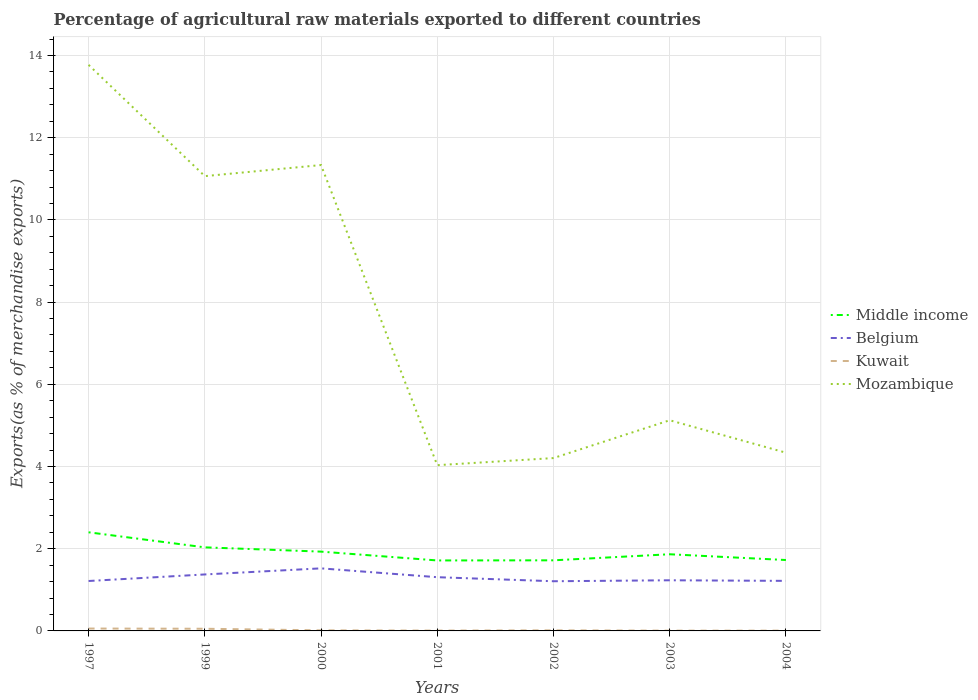How many different coloured lines are there?
Make the answer very short. 4. Is the number of lines equal to the number of legend labels?
Ensure brevity in your answer.  Yes. Across all years, what is the maximum percentage of exports to different countries in Belgium?
Provide a short and direct response. 1.21. What is the total percentage of exports to different countries in Kuwait in the graph?
Offer a terse response. 5.218391852740076e-5. What is the difference between the highest and the second highest percentage of exports to different countries in Middle income?
Your answer should be very brief. 0.68. How many lines are there?
Your answer should be compact. 4. How many years are there in the graph?
Make the answer very short. 7. What is the difference between two consecutive major ticks on the Y-axis?
Make the answer very short. 2. Are the values on the major ticks of Y-axis written in scientific E-notation?
Offer a terse response. No. Where does the legend appear in the graph?
Provide a short and direct response. Center right. How many legend labels are there?
Give a very brief answer. 4. What is the title of the graph?
Ensure brevity in your answer.  Percentage of agricultural raw materials exported to different countries. What is the label or title of the X-axis?
Your answer should be very brief. Years. What is the label or title of the Y-axis?
Keep it short and to the point. Exports(as % of merchandise exports). What is the Exports(as % of merchandise exports) of Middle income in 1997?
Your answer should be very brief. 2.4. What is the Exports(as % of merchandise exports) of Belgium in 1997?
Offer a very short reply. 1.21. What is the Exports(as % of merchandise exports) in Kuwait in 1997?
Keep it short and to the point. 0.06. What is the Exports(as % of merchandise exports) of Mozambique in 1997?
Make the answer very short. 13.77. What is the Exports(as % of merchandise exports) in Middle income in 1999?
Keep it short and to the point. 2.03. What is the Exports(as % of merchandise exports) of Belgium in 1999?
Offer a very short reply. 1.37. What is the Exports(as % of merchandise exports) in Kuwait in 1999?
Your answer should be compact. 0.05. What is the Exports(as % of merchandise exports) of Mozambique in 1999?
Offer a very short reply. 11.07. What is the Exports(as % of merchandise exports) of Middle income in 2000?
Your answer should be compact. 1.93. What is the Exports(as % of merchandise exports) in Belgium in 2000?
Offer a very short reply. 1.52. What is the Exports(as % of merchandise exports) of Kuwait in 2000?
Keep it short and to the point. 0.01. What is the Exports(as % of merchandise exports) of Mozambique in 2000?
Ensure brevity in your answer.  11.33. What is the Exports(as % of merchandise exports) in Middle income in 2001?
Keep it short and to the point. 1.71. What is the Exports(as % of merchandise exports) of Belgium in 2001?
Offer a very short reply. 1.31. What is the Exports(as % of merchandise exports) of Kuwait in 2001?
Make the answer very short. 0.01. What is the Exports(as % of merchandise exports) of Mozambique in 2001?
Provide a short and direct response. 4.03. What is the Exports(as % of merchandise exports) of Middle income in 2002?
Your response must be concise. 1.72. What is the Exports(as % of merchandise exports) in Belgium in 2002?
Offer a terse response. 1.21. What is the Exports(as % of merchandise exports) in Kuwait in 2002?
Your answer should be very brief. 0.01. What is the Exports(as % of merchandise exports) of Mozambique in 2002?
Make the answer very short. 4.21. What is the Exports(as % of merchandise exports) of Middle income in 2003?
Your answer should be very brief. 1.87. What is the Exports(as % of merchandise exports) in Belgium in 2003?
Provide a short and direct response. 1.23. What is the Exports(as % of merchandise exports) in Kuwait in 2003?
Keep it short and to the point. 0.01. What is the Exports(as % of merchandise exports) in Mozambique in 2003?
Offer a very short reply. 5.13. What is the Exports(as % of merchandise exports) in Middle income in 2004?
Ensure brevity in your answer.  1.73. What is the Exports(as % of merchandise exports) of Belgium in 2004?
Give a very brief answer. 1.22. What is the Exports(as % of merchandise exports) in Kuwait in 2004?
Offer a very short reply. 0.01. What is the Exports(as % of merchandise exports) of Mozambique in 2004?
Your answer should be very brief. 4.34. Across all years, what is the maximum Exports(as % of merchandise exports) in Middle income?
Your answer should be very brief. 2.4. Across all years, what is the maximum Exports(as % of merchandise exports) of Belgium?
Your answer should be compact. 1.52. Across all years, what is the maximum Exports(as % of merchandise exports) in Kuwait?
Give a very brief answer. 0.06. Across all years, what is the maximum Exports(as % of merchandise exports) of Mozambique?
Give a very brief answer. 13.77. Across all years, what is the minimum Exports(as % of merchandise exports) of Middle income?
Your response must be concise. 1.71. Across all years, what is the minimum Exports(as % of merchandise exports) in Belgium?
Provide a succinct answer. 1.21. Across all years, what is the minimum Exports(as % of merchandise exports) in Kuwait?
Give a very brief answer. 0.01. Across all years, what is the minimum Exports(as % of merchandise exports) in Mozambique?
Offer a very short reply. 4.03. What is the total Exports(as % of merchandise exports) in Middle income in the graph?
Make the answer very short. 13.38. What is the total Exports(as % of merchandise exports) in Belgium in the graph?
Offer a very short reply. 9.08. What is the total Exports(as % of merchandise exports) of Kuwait in the graph?
Ensure brevity in your answer.  0.16. What is the total Exports(as % of merchandise exports) in Mozambique in the graph?
Keep it short and to the point. 53.87. What is the difference between the Exports(as % of merchandise exports) of Middle income in 1997 and that in 1999?
Offer a terse response. 0.37. What is the difference between the Exports(as % of merchandise exports) in Belgium in 1997 and that in 1999?
Provide a short and direct response. -0.16. What is the difference between the Exports(as % of merchandise exports) in Kuwait in 1997 and that in 1999?
Keep it short and to the point. 0.01. What is the difference between the Exports(as % of merchandise exports) of Mozambique in 1997 and that in 1999?
Make the answer very short. 2.71. What is the difference between the Exports(as % of merchandise exports) of Middle income in 1997 and that in 2000?
Offer a terse response. 0.47. What is the difference between the Exports(as % of merchandise exports) in Belgium in 1997 and that in 2000?
Your answer should be compact. -0.31. What is the difference between the Exports(as % of merchandise exports) of Kuwait in 1997 and that in 2000?
Your response must be concise. 0.04. What is the difference between the Exports(as % of merchandise exports) in Mozambique in 1997 and that in 2000?
Your answer should be compact. 2.44. What is the difference between the Exports(as % of merchandise exports) of Middle income in 1997 and that in 2001?
Keep it short and to the point. 0.69. What is the difference between the Exports(as % of merchandise exports) in Belgium in 1997 and that in 2001?
Provide a short and direct response. -0.09. What is the difference between the Exports(as % of merchandise exports) in Kuwait in 1997 and that in 2001?
Provide a short and direct response. 0.05. What is the difference between the Exports(as % of merchandise exports) of Mozambique in 1997 and that in 2001?
Offer a very short reply. 9.74. What is the difference between the Exports(as % of merchandise exports) in Middle income in 1997 and that in 2002?
Your response must be concise. 0.68. What is the difference between the Exports(as % of merchandise exports) of Belgium in 1997 and that in 2002?
Provide a succinct answer. 0.01. What is the difference between the Exports(as % of merchandise exports) in Kuwait in 1997 and that in 2002?
Provide a short and direct response. 0.04. What is the difference between the Exports(as % of merchandise exports) of Mozambique in 1997 and that in 2002?
Provide a short and direct response. 9.57. What is the difference between the Exports(as % of merchandise exports) in Middle income in 1997 and that in 2003?
Keep it short and to the point. 0.53. What is the difference between the Exports(as % of merchandise exports) in Belgium in 1997 and that in 2003?
Ensure brevity in your answer.  -0.02. What is the difference between the Exports(as % of merchandise exports) in Kuwait in 1997 and that in 2003?
Your answer should be compact. 0.05. What is the difference between the Exports(as % of merchandise exports) of Mozambique in 1997 and that in 2003?
Keep it short and to the point. 8.65. What is the difference between the Exports(as % of merchandise exports) in Middle income in 1997 and that in 2004?
Keep it short and to the point. 0.67. What is the difference between the Exports(as % of merchandise exports) of Belgium in 1997 and that in 2004?
Provide a short and direct response. -0. What is the difference between the Exports(as % of merchandise exports) of Kuwait in 1997 and that in 2004?
Offer a very short reply. 0.05. What is the difference between the Exports(as % of merchandise exports) in Mozambique in 1997 and that in 2004?
Ensure brevity in your answer.  9.44. What is the difference between the Exports(as % of merchandise exports) of Middle income in 1999 and that in 2000?
Keep it short and to the point. 0.1. What is the difference between the Exports(as % of merchandise exports) in Belgium in 1999 and that in 2000?
Provide a short and direct response. -0.15. What is the difference between the Exports(as % of merchandise exports) in Kuwait in 1999 and that in 2000?
Provide a short and direct response. 0.04. What is the difference between the Exports(as % of merchandise exports) of Mozambique in 1999 and that in 2000?
Make the answer very short. -0.27. What is the difference between the Exports(as % of merchandise exports) of Middle income in 1999 and that in 2001?
Keep it short and to the point. 0.32. What is the difference between the Exports(as % of merchandise exports) of Belgium in 1999 and that in 2001?
Your answer should be compact. 0.07. What is the difference between the Exports(as % of merchandise exports) in Kuwait in 1999 and that in 2001?
Make the answer very short. 0.04. What is the difference between the Exports(as % of merchandise exports) of Mozambique in 1999 and that in 2001?
Keep it short and to the point. 7.03. What is the difference between the Exports(as % of merchandise exports) in Middle income in 1999 and that in 2002?
Your answer should be compact. 0.32. What is the difference between the Exports(as % of merchandise exports) of Belgium in 1999 and that in 2002?
Your answer should be very brief. 0.17. What is the difference between the Exports(as % of merchandise exports) in Kuwait in 1999 and that in 2002?
Keep it short and to the point. 0.04. What is the difference between the Exports(as % of merchandise exports) in Mozambique in 1999 and that in 2002?
Your response must be concise. 6.86. What is the difference between the Exports(as % of merchandise exports) in Middle income in 1999 and that in 2003?
Ensure brevity in your answer.  0.17. What is the difference between the Exports(as % of merchandise exports) in Belgium in 1999 and that in 2003?
Your response must be concise. 0.14. What is the difference between the Exports(as % of merchandise exports) in Kuwait in 1999 and that in 2003?
Your answer should be very brief. 0.05. What is the difference between the Exports(as % of merchandise exports) of Mozambique in 1999 and that in 2003?
Offer a terse response. 5.94. What is the difference between the Exports(as % of merchandise exports) of Middle income in 1999 and that in 2004?
Keep it short and to the point. 0.31. What is the difference between the Exports(as % of merchandise exports) in Belgium in 1999 and that in 2004?
Provide a succinct answer. 0.16. What is the difference between the Exports(as % of merchandise exports) in Kuwait in 1999 and that in 2004?
Offer a terse response. 0.05. What is the difference between the Exports(as % of merchandise exports) in Mozambique in 1999 and that in 2004?
Your response must be concise. 6.73. What is the difference between the Exports(as % of merchandise exports) in Middle income in 2000 and that in 2001?
Keep it short and to the point. 0.21. What is the difference between the Exports(as % of merchandise exports) in Belgium in 2000 and that in 2001?
Make the answer very short. 0.21. What is the difference between the Exports(as % of merchandise exports) in Kuwait in 2000 and that in 2001?
Give a very brief answer. 0.01. What is the difference between the Exports(as % of merchandise exports) in Mozambique in 2000 and that in 2001?
Make the answer very short. 7.3. What is the difference between the Exports(as % of merchandise exports) in Middle income in 2000 and that in 2002?
Give a very brief answer. 0.21. What is the difference between the Exports(as % of merchandise exports) of Belgium in 2000 and that in 2002?
Your answer should be compact. 0.31. What is the difference between the Exports(as % of merchandise exports) of Kuwait in 2000 and that in 2002?
Provide a succinct answer. -0. What is the difference between the Exports(as % of merchandise exports) in Mozambique in 2000 and that in 2002?
Your answer should be compact. 7.13. What is the difference between the Exports(as % of merchandise exports) of Middle income in 2000 and that in 2003?
Ensure brevity in your answer.  0.06. What is the difference between the Exports(as % of merchandise exports) of Belgium in 2000 and that in 2003?
Provide a succinct answer. 0.29. What is the difference between the Exports(as % of merchandise exports) of Kuwait in 2000 and that in 2003?
Give a very brief answer. 0.01. What is the difference between the Exports(as % of merchandise exports) of Mozambique in 2000 and that in 2003?
Your answer should be very brief. 6.21. What is the difference between the Exports(as % of merchandise exports) of Middle income in 2000 and that in 2004?
Ensure brevity in your answer.  0.2. What is the difference between the Exports(as % of merchandise exports) of Belgium in 2000 and that in 2004?
Provide a short and direct response. 0.3. What is the difference between the Exports(as % of merchandise exports) of Kuwait in 2000 and that in 2004?
Provide a short and direct response. 0.01. What is the difference between the Exports(as % of merchandise exports) of Mozambique in 2000 and that in 2004?
Your answer should be very brief. 7. What is the difference between the Exports(as % of merchandise exports) in Middle income in 2001 and that in 2002?
Offer a very short reply. -0. What is the difference between the Exports(as % of merchandise exports) in Belgium in 2001 and that in 2002?
Provide a succinct answer. 0.1. What is the difference between the Exports(as % of merchandise exports) of Kuwait in 2001 and that in 2002?
Ensure brevity in your answer.  -0.01. What is the difference between the Exports(as % of merchandise exports) of Mozambique in 2001 and that in 2002?
Your answer should be compact. -0.17. What is the difference between the Exports(as % of merchandise exports) in Middle income in 2001 and that in 2003?
Provide a short and direct response. -0.15. What is the difference between the Exports(as % of merchandise exports) of Belgium in 2001 and that in 2003?
Ensure brevity in your answer.  0.08. What is the difference between the Exports(as % of merchandise exports) in Kuwait in 2001 and that in 2003?
Make the answer very short. 0. What is the difference between the Exports(as % of merchandise exports) in Mozambique in 2001 and that in 2003?
Give a very brief answer. -1.09. What is the difference between the Exports(as % of merchandise exports) in Middle income in 2001 and that in 2004?
Your answer should be very brief. -0.01. What is the difference between the Exports(as % of merchandise exports) of Belgium in 2001 and that in 2004?
Ensure brevity in your answer.  0.09. What is the difference between the Exports(as % of merchandise exports) in Kuwait in 2001 and that in 2004?
Your answer should be compact. 0. What is the difference between the Exports(as % of merchandise exports) of Mozambique in 2001 and that in 2004?
Keep it short and to the point. -0.3. What is the difference between the Exports(as % of merchandise exports) in Middle income in 2002 and that in 2003?
Your answer should be very brief. -0.15. What is the difference between the Exports(as % of merchandise exports) of Belgium in 2002 and that in 2003?
Offer a terse response. -0.02. What is the difference between the Exports(as % of merchandise exports) of Kuwait in 2002 and that in 2003?
Your answer should be compact. 0.01. What is the difference between the Exports(as % of merchandise exports) of Mozambique in 2002 and that in 2003?
Make the answer very short. -0.92. What is the difference between the Exports(as % of merchandise exports) of Middle income in 2002 and that in 2004?
Offer a very short reply. -0.01. What is the difference between the Exports(as % of merchandise exports) of Belgium in 2002 and that in 2004?
Offer a very short reply. -0.01. What is the difference between the Exports(as % of merchandise exports) in Kuwait in 2002 and that in 2004?
Ensure brevity in your answer.  0.01. What is the difference between the Exports(as % of merchandise exports) of Mozambique in 2002 and that in 2004?
Offer a terse response. -0.13. What is the difference between the Exports(as % of merchandise exports) of Middle income in 2003 and that in 2004?
Keep it short and to the point. 0.14. What is the difference between the Exports(as % of merchandise exports) of Belgium in 2003 and that in 2004?
Your answer should be compact. 0.01. What is the difference between the Exports(as % of merchandise exports) in Mozambique in 2003 and that in 2004?
Make the answer very short. 0.79. What is the difference between the Exports(as % of merchandise exports) in Middle income in 1997 and the Exports(as % of merchandise exports) in Belgium in 1999?
Provide a succinct answer. 1.03. What is the difference between the Exports(as % of merchandise exports) of Middle income in 1997 and the Exports(as % of merchandise exports) of Kuwait in 1999?
Give a very brief answer. 2.35. What is the difference between the Exports(as % of merchandise exports) of Middle income in 1997 and the Exports(as % of merchandise exports) of Mozambique in 1999?
Give a very brief answer. -8.67. What is the difference between the Exports(as % of merchandise exports) of Belgium in 1997 and the Exports(as % of merchandise exports) of Kuwait in 1999?
Offer a terse response. 1.16. What is the difference between the Exports(as % of merchandise exports) in Belgium in 1997 and the Exports(as % of merchandise exports) in Mozambique in 1999?
Your answer should be very brief. -9.85. What is the difference between the Exports(as % of merchandise exports) in Kuwait in 1997 and the Exports(as % of merchandise exports) in Mozambique in 1999?
Give a very brief answer. -11.01. What is the difference between the Exports(as % of merchandise exports) in Middle income in 1997 and the Exports(as % of merchandise exports) in Belgium in 2000?
Offer a terse response. 0.88. What is the difference between the Exports(as % of merchandise exports) of Middle income in 1997 and the Exports(as % of merchandise exports) of Kuwait in 2000?
Your response must be concise. 2.39. What is the difference between the Exports(as % of merchandise exports) of Middle income in 1997 and the Exports(as % of merchandise exports) of Mozambique in 2000?
Provide a succinct answer. -8.94. What is the difference between the Exports(as % of merchandise exports) of Belgium in 1997 and the Exports(as % of merchandise exports) of Kuwait in 2000?
Your answer should be compact. 1.2. What is the difference between the Exports(as % of merchandise exports) in Belgium in 1997 and the Exports(as % of merchandise exports) in Mozambique in 2000?
Provide a succinct answer. -10.12. What is the difference between the Exports(as % of merchandise exports) of Kuwait in 1997 and the Exports(as % of merchandise exports) of Mozambique in 2000?
Your response must be concise. -11.28. What is the difference between the Exports(as % of merchandise exports) of Middle income in 1997 and the Exports(as % of merchandise exports) of Belgium in 2001?
Offer a terse response. 1.09. What is the difference between the Exports(as % of merchandise exports) of Middle income in 1997 and the Exports(as % of merchandise exports) of Kuwait in 2001?
Provide a succinct answer. 2.39. What is the difference between the Exports(as % of merchandise exports) of Middle income in 1997 and the Exports(as % of merchandise exports) of Mozambique in 2001?
Make the answer very short. -1.63. What is the difference between the Exports(as % of merchandise exports) in Belgium in 1997 and the Exports(as % of merchandise exports) in Kuwait in 2001?
Ensure brevity in your answer.  1.21. What is the difference between the Exports(as % of merchandise exports) of Belgium in 1997 and the Exports(as % of merchandise exports) of Mozambique in 2001?
Offer a very short reply. -2.82. What is the difference between the Exports(as % of merchandise exports) of Kuwait in 1997 and the Exports(as % of merchandise exports) of Mozambique in 2001?
Ensure brevity in your answer.  -3.97. What is the difference between the Exports(as % of merchandise exports) in Middle income in 1997 and the Exports(as % of merchandise exports) in Belgium in 2002?
Offer a terse response. 1.19. What is the difference between the Exports(as % of merchandise exports) in Middle income in 1997 and the Exports(as % of merchandise exports) in Kuwait in 2002?
Keep it short and to the point. 2.39. What is the difference between the Exports(as % of merchandise exports) of Middle income in 1997 and the Exports(as % of merchandise exports) of Mozambique in 2002?
Offer a very short reply. -1.81. What is the difference between the Exports(as % of merchandise exports) in Belgium in 1997 and the Exports(as % of merchandise exports) in Kuwait in 2002?
Your answer should be very brief. 1.2. What is the difference between the Exports(as % of merchandise exports) of Belgium in 1997 and the Exports(as % of merchandise exports) of Mozambique in 2002?
Provide a succinct answer. -2.99. What is the difference between the Exports(as % of merchandise exports) in Kuwait in 1997 and the Exports(as % of merchandise exports) in Mozambique in 2002?
Your answer should be very brief. -4.15. What is the difference between the Exports(as % of merchandise exports) of Middle income in 1997 and the Exports(as % of merchandise exports) of Belgium in 2003?
Your answer should be very brief. 1.17. What is the difference between the Exports(as % of merchandise exports) of Middle income in 1997 and the Exports(as % of merchandise exports) of Kuwait in 2003?
Give a very brief answer. 2.39. What is the difference between the Exports(as % of merchandise exports) in Middle income in 1997 and the Exports(as % of merchandise exports) in Mozambique in 2003?
Give a very brief answer. -2.73. What is the difference between the Exports(as % of merchandise exports) in Belgium in 1997 and the Exports(as % of merchandise exports) in Kuwait in 2003?
Offer a terse response. 1.21. What is the difference between the Exports(as % of merchandise exports) in Belgium in 1997 and the Exports(as % of merchandise exports) in Mozambique in 2003?
Offer a terse response. -3.91. What is the difference between the Exports(as % of merchandise exports) of Kuwait in 1997 and the Exports(as % of merchandise exports) of Mozambique in 2003?
Provide a short and direct response. -5.07. What is the difference between the Exports(as % of merchandise exports) in Middle income in 1997 and the Exports(as % of merchandise exports) in Belgium in 2004?
Provide a succinct answer. 1.18. What is the difference between the Exports(as % of merchandise exports) of Middle income in 1997 and the Exports(as % of merchandise exports) of Kuwait in 2004?
Give a very brief answer. 2.39. What is the difference between the Exports(as % of merchandise exports) in Middle income in 1997 and the Exports(as % of merchandise exports) in Mozambique in 2004?
Ensure brevity in your answer.  -1.94. What is the difference between the Exports(as % of merchandise exports) in Belgium in 1997 and the Exports(as % of merchandise exports) in Kuwait in 2004?
Give a very brief answer. 1.21. What is the difference between the Exports(as % of merchandise exports) in Belgium in 1997 and the Exports(as % of merchandise exports) in Mozambique in 2004?
Give a very brief answer. -3.12. What is the difference between the Exports(as % of merchandise exports) in Kuwait in 1997 and the Exports(as % of merchandise exports) in Mozambique in 2004?
Provide a succinct answer. -4.28. What is the difference between the Exports(as % of merchandise exports) in Middle income in 1999 and the Exports(as % of merchandise exports) in Belgium in 2000?
Keep it short and to the point. 0.51. What is the difference between the Exports(as % of merchandise exports) of Middle income in 1999 and the Exports(as % of merchandise exports) of Kuwait in 2000?
Make the answer very short. 2.02. What is the difference between the Exports(as % of merchandise exports) of Middle income in 1999 and the Exports(as % of merchandise exports) of Mozambique in 2000?
Ensure brevity in your answer.  -9.3. What is the difference between the Exports(as % of merchandise exports) in Belgium in 1999 and the Exports(as % of merchandise exports) in Kuwait in 2000?
Your response must be concise. 1.36. What is the difference between the Exports(as % of merchandise exports) in Belgium in 1999 and the Exports(as % of merchandise exports) in Mozambique in 2000?
Provide a succinct answer. -9.96. What is the difference between the Exports(as % of merchandise exports) in Kuwait in 1999 and the Exports(as % of merchandise exports) in Mozambique in 2000?
Your answer should be compact. -11.28. What is the difference between the Exports(as % of merchandise exports) of Middle income in 1999 and the Exports(as % of merchandise exports) of Belgium in 2001?
Provide a short and direct response. 0.73. What is the difference between the Exports(as % of merchandise exports) of Middle income in 1999 and the Exports(as % of merchandise exports) of Kuwait in 2001?
Keep it short and to the point. 2.02. What is the difference between the Exports(as % of merchandise exports) in Middle income in 1999 and the Exports(as % of merchandise exports) in Mozambique in 2001?
Provide a succinct answer. -2. What is the difference between the Exports(as % of merchandise exports) in Belgium in 1999 and the Exports(as % of merchandise exports) in Kuwait in 2001?
Provide a succinct answer. 1.37. What is the difference between the Exports(as % of merchandise exports) of Belgium in 1999 and the Exports(as % of merchandise exports) of Mozambique in 2001?
Your response must be concise. -2.66. What is the difference between the Exports(as % of merchandise exports) in Kuwait in 1999 and the Exports(as % of merchandise exports) in Mozambique in 2001?
Your response must be concise. -3.98. What is the difference between the Exports(as % of merchandise exports) of Middle income in 1999 and the Exports(as % of merchandise exports) of Belgium in 2002?
Provide a short and direct response. 0.82. What is the difference between the Exports(as % of merchandise exports) of Middle income in 1999 and the Exports(as % of merchandise exports) of Kuwait in 2002?
Your answer should be compact. 2.02. What is the difference between the Exports(as % of merchandise exports) in Middle income in 1999 and the Exports(as % of merchandise exports) in Mozambique in 2002?
Provide a succinct answer. -2.17. What is the difference between the Exports(as % of merchandise exports) of Belgium in 1999 and the Exports(as % of merchandise exports) of Kuwait in 2002?
Your answer should be compact. 1.36. What is the difference between the Exports(as % of merchandise exports) of Belgium in 1999 and the Exports(as % of merchandise exports) of Mozambique in 2002?
Offer a terse response. -2.83. What is the difference between the Exports(as % of merchandise exports) of Kuwait in 1999 and the Exports(as % of merchandise exports) of Mozambique in 2002?
Ensure brevity in your answer.  -4.15. What is the difference between the Exports(as % of merchandise exports) in Middle income in 1999 and the Exports(as % of merchandise exports) in Belgium in 2003?
Ensure brevity in your answer.  0.8. What is the difference between the Exports(as % of merchandise exports) of Middle income in 1999 and the Exports(as % of merchandise exports) of Kuwait in 2003?
Give a very brief answer. 2.03. What is the difference between the Exports(as % of merchandise exports) in Middle income in 1999 and the Exports(as % of merchandise exports) in Mozambique in 2003?
Make the answer very short. -3.09. What is the difference between the Exports(as % of merchandise exports) of Belgium in 1999 and the Exports(as % of merchandise exports) of Kuwait in 2003?
Give a very brief answer. 1.37. What is the difference between the Exports(as % of merchandise exports) of Belgium in 1999 and the Exports(as % of merchandise exports) of Mozambique in 2003?
Give a very brief answer. -3.75. What is the difference between the Exports(as % of merchandise exports) in Kuwait in 1999 and the Exports(as % of merchandise exports) in Mozambique in 2003?
Give a very brief answer. -5.07. What is the difference between the Exports(as % of merchandise exports) of Middle income in 1999 and the Exports(as % of merchandise exports) of Belgium in 2004?
Your answer should be very brief. 0.82. What is the difference between the Exports(as % of merchandise exports) in Middle income in 1999 and the Exports(as % of merchandise exports) in Kuwait in 2004?
Offer a terse response. 2.03. What is the difference between the Exports(as % of merchandise exports) in Middle income in 1999 and the Exports(as % of merchandise exports) in Mozambique in 2004?
Your answer should be compact. -2.3. What is the difference between the Exports(as % of merchandise exports) in Belgium in 1999 and the Exports(as % of merchandise exports) in Kuwait in 2004?
Your response must be concise. 1.37. What is the difference between the Exports(as % of merchandise exports) of Belgium in 1999 and the Exports(as % of merchandise exports) of Mozambique in 2004?
Keep it short and to the point. -2.96. What is the difference between the Exports(as % of merchandise exports) in Kuwait in 1999 and the Exports(as % of merchandise exports) in Mozambique in 2004?
Provide a succinct answer. -4.28. What is the difference between the Exports(as % of merchandise exports) of Middle income in 2000 and the Exports(as % of merchandise exports) of Belgium in 2001?
Your answer should be very brief. 0.62. What is the difference between the Exports(as % of merchandise exports) in Middle income in 2000 and the Exports(as % of merchandise exports) in Kuwait in 2001?
Your response must be concise. 1.92. What is the difference between the Exports(as % of merchandise exports) of Middle income in 2000 and the Exports(as % of merchandise exports) of Mozambique in 2001?
Offer a very short reply. -2.1. What is the difference between the Exports(as % of merchandise exports) of Belgium in 2000 and the Exports(as % of merchandise exports) of Kuwait in 2001?
Your answer should be compact. 1.51. What is the difference between the Exports(as % of merchandise exports) of Belgium in 2000 and the Exports(as % of merchandise exports) of Mozambique in 2001?
Keep it short and to the point. -2.51. What is the difference between the Exports(as % of merchandise exports) of Kuwait in 2000 and the Exports(as % of merchandise exports) of Mozambique in 2001?
Give a very brief answer. -4.02. What is the difference between the Exports(as % of merchandise exports) of Middle income in 2000 and the Exports(as % of merchandise exports) of Belgium in 2002?
Your answer should be compact. 0.72. What is the difference between the Exports(as % of merchandise exports) in Middle income in 2000 and the Exports(as % of merchandise exports) in Kuwait in 2002?
Offer a very short reply. 1.92. What is the difference between the Exports(as % of merchandise exports) of Middle income in 2000 and the Exports(as % of merchandise exports) of Mozambique in 2002?
Give a very brief answer. -2.28. What is the difference between the Exports(as % of merchandise exports) in Belgium in 2000 and the Exports(as % of merchandise exports) in Kuwait in 2002?
Ensure brevity in your answer.  1.51. What is the difference between the Exports(as % of merchandise exports) of Belgium in 2000 and the Exports(as % of merchandise exports) of Mozambique in 2002?
Make the answer very short. -2.68. What is the difference between the Exports(as % of merchandise exports) in Kuwait in 2000 and the Exports(as % of merchandise exports) in Mozambique in 2002?
Offer a very short reply. -4.19. What is the difference between the Exports(as % of merchandise exports) of Middle income in 2000 and the Exports(as % of merchandise exports) of Belgium in 2003?
Your response must be concise. 0.7. What is the difference between the Exports(as % of merchandise exports) in Middle income in 2000 and the Exports(as % of merchandise exports) in Kuwait in 2003?
Give a very brief answer. 1.92. What is the difference between the Exports(as % of merchandise exports) of Middle income in 2000 and the Exports(as % of merchandise exports) of Mozambique in 2003?
Your answer should be very brief. -3.2. What is the difference between the Exports(as % of merchandise exports) in Belgium in 2000 and the Exports(as % of merchandise exports) in Kuwait in 2003?
Provide a succinct answer. 1.52. What is the difference between the Exports(as % of merchandise exports) in Belgium in 2000 and the Exports(as % of merchandise exports) in Mozambique in 2003?
Your answer should be compact. -3.6. What is the difference between the Exports(as % of merchandise exports) in Kuwait in 2000 and the Exports(as % of merchandise exports) in Mozambique in 2003?
Provide a short and direct response. -5.11. What is the difference between the Exports(as % of merchandise exports) of Middle income in 2000 and the Exports(as % of merchandise exports) of Belgium in 2004?
Your answer should be very brief. 0.71. What is the difference between the Exports(as % of merchandise exports) in Middle income in 2000 and the Exports(as % of merchandise exports) in Kuwait in 2004?
Provide a short and direct response. 1.92. What is the difference between the Exports(as % of merchandise exports) in Middle income in 2000 and the Exports(as % of merchandise exports) in Mozambique in 2004?
Give a very brief answer. -2.41. What is the difference between the Exports(as % of merchandise exports) in Belgium in 2000 and the Exports(as % of merchandise exports) in Kuwait in 2004?
Ensure brevity in your answer.  1.52. What is the difference between the Exports(as % of merchandise exports) in Belgium in 2000 and the Exports(as % of merchandise exports) in Mozambique in 2004?
Ensure brevity in your answer.  -2.81. What is the difference between the Exports(as % of merchandise exports) in Kuwait in 2000 and the Exports(as % of merchandise exports) in Mozambique in 2004?
Ensure brevity in your answer.  -4.32. What is the difference between the Exports(as % of merchandise exports) of Middle income in 2001 and the Exports(as % of merchandise exports) of Belgium in 2002?
Offer a terse response. 0.51. What is the difference between the Exports(as % of merchandise exports) of Middle income in 2001 and the Exports(as % of merchandise exports) of Kuwait in 2002?
Offer a very short reply. 1.7. What is the difference between the Exports(as % of merchandise exports) in Middle income in 2001 and the Exports(as % of merchandise exports) in Mozambique in 2002?
Ensure brevity in your answer.  -2.49. What is the difference between the Exports(as % of merchandise exports) of Belgium in 2001 and the Exports(as % of merchandise exports) of Kuwait in 2002?
Give a very brief answer. 1.29. What is the difference between the Exports(as % of merchandise exports) of Belgium in 2001 and the Exports(as % of merchandise exports) of Mozambique in 2002?
Make the answer very short. -2.9. What is the difference between the Exports(as % of merchandise exports) of Kuwait in 2001 and the Exports(as % of merchandise exports) of Mozambique in 2002?
Your answer should be compact. -4.2. What is the difference between the Exports(as % of merchandise exports) of Middle income in 2001 and the Exports(as % of merchandise exports) of Belgium in 2003?
Make the answer very short. 0.48. What is the difference between the Exports(as % of merchandise exports) of Middle income in 2001 and the Exports(as % of merchandise exports) of Kuwait in 2003?
Offer a very short reply. 1.71. What is the difference between the Exports(as % of merchandise exports) of Middle income in 2001 and the Exports(as % of merchandise exports) of Mozambique in 2003?
Offer a terse response. -3.41. What is the difference between the Exports(as % of merchandise exports) in Belgium in 2001 and the Exports(as % of merchandise exports) in Kuwait in 2003?
Offer a very short reply. 1.3. What is the difference between the Exports(as % of merchandise exports) of Belgium in 2001 and the Exports(as % of merchandise exports) of Mozambique in 2003?
Give a very brief answer. -3.82. What is the difference between the Exports(as % of merchandise exports) in Kuwait in 2001 and the Exports(as % of merchandise exports) in Mozambique in 2003?
Your answer should be very brief. -5.12. What is the difference between the Exports(as % of merchandise exports) of Middle income in 2001 and the Exports(as % of merchandise exports) of Belgium in 2004?
Offer a terse response. 0.5. What is the difference between the Exports(as % of merchandise exports) in Middle income in 2001 and the Exports(as % of merchandise exports) in Kuwait in 2004?
Offer a very short reply. 1.71. What is the difference between the Exports(as % of merchandise exports) in Middle income in 2001 and the Exports(as % of merchandise exports) in Mozambique in 2004?
Give a very brief answer. -2.62. What is the difference between the Exports(as % of merchandise exports) in Belgium in 2001 and the Exports(as % of merchandise exports) in Kuwait in 2004?
Provide a short and direct response. 1.3. What is the difference between the Exports(as % of merchandise exports) of Belgium in 2001 and the Exports(as % of merchandise exports) of Mozambique in 2004?
Keep it short and to the point. -3.03. What is the difference between the Exports(as % of merchandise exports) in Kuwait in 2001 and the Exports(as % of merchandise exports) in Mozambique in 2004?
Your response must be concise. -4.33. What is the difference between the Exports(as % of merchandise exports) in Middle income in 2002 and the Exports(as % of merchandise exports) in Belgium in 2003?
Your answer should be very brief. 0.49. What is the difference between the Exports(as % of merchandise exports) of Middle income in 2002 and the Exports(as % of merchandise exports) of Kuwait in 2003?
Your answer should be very brief. 1.71. What is the difference between the Exports(as % of merchandise exports) in Middle income in 2002 and the Exports(as % of merchandise exports) in Mozambique in 2003?
Make the answer very short. -3.41. What is the difference between the Exports(as % of merchandise exports) of Belgium in 2002 and the Exports(as % of merchandise exports) of Kuwait in 2003?
Keep it short and to the point. 1.2. What is the difference between the Exports(as % of merchandise exports) in Belgium in 2002 and the Exports(as % of merchandise exports) in Mozambique in 2003?
Keep it short and to the point. -3.92. What is the difference between the Exports(as % of merchandise exports) in Kuwait in 2002 and the Exports(as % of merchandise exports) in Mozambique in 2003?
Offer a terse response. -5.11. What is the difference between the Exports(as % of merchandise exports) of Middle income in 2002 and the Exports(as % of merchandise exports) of Belgium in 2004?
Provide a succinct answer. 0.5. What is the difference between the Exports(as % of merchandise exports) of Middle income in 2002 and the Exports(as % of merchandise exports) of Kuwait in 2004?
Offer a very short reply. 1.71. What is the difference between the Exports(as % of merchandise exports) of Middle income in 2002 and the Exports(as % of merchandise exports) of Mozambique in 2004?
Make the answer very short. -2.62. What is the difference between the Exports(as % of merchandise exports) of Belgium in 2002 and the Exports(as % of merchandise exports) of Kuwait in 2004?
Offer a terse response. 1.2. What is the difference between the Exports(as % of merchandise exports) in Belgium in 2002 and the Exports(as % of merchandise exports) in Mozambique in 2004?
Ensure brevity in your answer.  -3.13. What is the difference between the Exports(as % of merchandise exports) in Kuwait in 2002 and the Exports(as % of merchandise exports) in Mozambique in 2004?
Provide a short and direct response. -4.32. What is the difference between the Exports(as % of merchandise exports) of Middle income in 2003 and the Exports(as % of merchandise exports) of Belgium in 2004?
Offer a terse response. 0.65. What is the difference between the Exports(as % of merchandise exports) in Middle income in 2003 and the Exports(as % of merchandise exports) in Kuwait in 2004?
Make the answer very short. 1.86. What is the difference between the Exports(as % of merchandise exports) in Middle income in 2003 and the Exports(as % of merchandise exports) in Mozambique in 2004?
Your response must be concise. -2.47. What is the difference between the Exports(as % of merchandise exports) in Belgium in 2003 and the Exports(as % of merchandise exports) in Kuwait in 2004?
Offer a very short reply. 1.23. What is the difference between the Exports(as % of merchandise exports) in Belgium in 2003 and the Exports(as % of merchandise exports) in Mozambique in 2004?
Your answer should be very brief. -3.1. What is the difference between the Exports(as % of merchandise exports) in Kuwait in 2003 and the Exports(as % of merchandise exports) in Mozambique in 2004?
Your response must be concise. -4.33. What is the average Exports(as % of merchandise exports) of Middle income per year?
Offer a terse response. 1.91. What is the average Exports(as % of merchandise exports) in Belgium per year?
Provide a succinct answer. 1.3. What is the average Exports(as % of merchandise exports) of Kuwait per year?
Give a very brief answer. 0.02. What is the average Exports(as % of merchandise exports) in Mozambique per year?
Ensure brevity in your answer.  7.7. In the year 1997, what is the difference between the Exports(as % of merchandise exports) of Middle income and Exports(as % of merchandise exports) of Belgium?
Give a very brief answer. 1.19. In the year 1997, what is the difference between the Exports(as % of merchandise exports) of Middle income and Exports(as % of merchandise exports) of Kuwait?
Offer a very short reply. 2.34. In the year 1997, what is the difference between the Exports(as % of merchandise exports) of Middle income and Exports(as % of merchandise exports) of Mozambique?
Provide a short and direct response. -11.37. In the year 1997, what is the difference between the Exports(as % of merchandise exports) of Belgium and Exports(as % of merchandise exports) of Kuwait?
Offer a very short reply. 1.16. In the year 1997, what is the difference between the Exports(as % of merchandise exports) in Belgium and Exports(as % of merchandise exports) in Mozambique?
Give a very brief answer. -12.56. In the year 1997, what is the difference between the Exports(as % of merchandise exports) of Kuwait and Exports(as % of merchandise exports) of Mozambique?
Provide a succinct answer. -13.71. In the year 1999, what is the difference between the Exports(as % of merchandise exports) of Middle income and Exports(as % of merchandise exports) of Belgium?
Keep it short and to the point. 0.66. In the year 1999, what is the difference between the Exports(as % of merchandise exports) of Middle income and Exports(as % of merchandise exports) of Kuwait?
Give a very brief answer. 1.98. In the year 1999, what is the difference between the Exports(as % of merchandise exports) in Middle income and Exports(as % of merchandise exports) in Mozambique?
Provide a succinct answer. -9.03. In the year 1999, what is the difference between the Exports(as % of merchandise exports) in Belgium and Exports(as % of merchandise exports) in Kuwait?
Provide a short and direct response. 1.32. In the year 1999, what is the difference between the Exports(as % of merchandise exports) of Belgium and Exports(as % of merchandise exports) of Mozambique?
Your response must be concise. -9.69. In the year 1999, what is the difference between the Exports(as % of merchandise exports) of Kuwait and Exports(as % of merchandise exports) of Mozambique?
Keep it short and to the point. -11.01. In the year 2000, what is the difference between the Exports(as % of merchandise exports) of Middle income and Exports(as % of merchandise exports) of Belgium?
Your answer should be compact. 0.41. In the year 2000, what is the difference between the Exports(as % of merchandise exports) of Middle income and Exports(as % of merchandise exports) of Kuwait?
Offer a very short reply. 1.92. In the year 2000, what is the difference between the Exports(as % of merchandise exports) of Middle income and Exports(as % of merchandise exports) of Mozambique?
Make the answer very short. -9.41. In the year 2000, what is the difference between the Exports(as % of merchandise exports) of Belgium and Exports(as % of merchandise exports) of Kuwait?
Offer a terse response. 1.51. In the year 2000, what is the difference between the Exports(as % of merchandise exports) in Belgium and Exports(as % of merchandise exports) in Mozambique?
Ensure brevity in your answer.  -9.81. In the year 2000, what is the difference between the Exports(as % of merchandise exports) in Kuwait and Exports(as % of merchandise exports) in Mozambique?
Offer a terse response. -11.32. In the year 2001, what is the difference between the Exports(as % of merchandise exports) in Middle income and Exports(as % of merchandise exports) in Belgium?
Your answer should be very brief. 0.41. In the year 2001, what is the difference between the Exports(as % of merchandise exports) of Middle income and Exports(as % of merchandise exports) of Kuwait?
Provide a short and direct response. 1.71. In the year 2001, what is the difference between the Exports(as % of merchandise exports) of Middle income and Exports(as % of merchandise exports) of Mozambique?
Give a very brief answer. -2.32. In the year 2001, what is the difference between the Exports(as % of merchandise exports) of Belgium and Exports(as % of merchandise exports) of Kuwait?
Your response must be concise. 1.3. In the year 2001, what is the difference between the Exports(as % of merchandise exports) of Belgium and Exports(as % of merchandise exports) of Mozambique?
Keep it short and to the point. -2.73. In the year 2001, what is the difference between the Exports(as % of merchandise exports) in Kuwait and Exports(as % of merchandise exports) in Mozambique?
Offer a terse response. -4.02. In the year 2002, what is the difference between the Exports(as % of merchandise exports) in Middle income and Exports(as % of merchandise exports) in Belgium?
Provide a succinct answer. 0.51. In the year 2002, what is the difference between the Exports(as % of merchandise exports) of Middle income and Exports(as % of merchandise exports) of Kuwait?
Your answer should be very brief. 1.7. In the year 2002, what is the difference between the Exports(as % of merchandise exports) of Middle income and Exports(as % of merchandise exports) of Mozambique?
Your response must be concise. -2.49. In the year 2002, what is the difference between the Exports(as % of merchandise exports) in Belgium and Exports(as % of merchandise exports) in Kuwait?
Your response must be concise. 1.19. In the year 2002, what is the difference between the Exports(as % of merchandise exports) of Belgium and Exports(as % of merchandise exports) of Mozambique?
Your answer should be very brief. -3. In the year 2002, what is the difference between the Exports(as % of merchandise exports) in Kuwait and Exports(as % of merchandise exports) in Mozambique?
Offer a terse response. -4.19. In the year 2003, what is the difference between the Exports(as % of merchandise exports) of Middle income and Exports(as % of merchandise exports) of Belgium?
Ensure brevity in your answer.  0.63. In the year 2003, what is the difference between the Exports(as % of merchandise exports) in Middle income and Exports(as % of merchandise exports) in Kuwait?
Provide a succinct answer. 1.86. In the year 2003, what is the difference between the Exports(as % of merchandise exports) of Middle income and Exports(as % of merchandise exports) of Mozambique?
Provide a short and direct response. -3.26. In the year 2003, what is the difference between the Exports(as % of merchandise exports) in Belgium and Exports(as % of merchandise exports) in Kuwait?
Provide a succinct answer. 1.23. In the year 2003, what is the difference between the Exports(as % of merchandise exports) of Belgium and Exports(as % of merchandise exports) of Mozambique?
Ensure brevity in your answer.  -3.89. In the year 2003, what is the difference between the Exports(as % of merchandise exports) of Kuwait and Exports(as % of merchandise exports) of Mozambique?
Offer a very short reply. -5.12. In the year 2004, what is the difference between the Exports(as % of merchandise exports) in Middle income and Exports(as % of merchandise exports) in Belgium?
Give a very brief answer. 0.51. In the year 2004, what is the difference between the Exports(as % of merchandise exports) of Middle income and Exports(as % of merchandise exports) of Kuwait?
Offer a terse response. 1.72. In the year 2004, what is the difference between the Exports(as % of merchandise exports) of Middle income and Exports(as % of merchandise exports) of Mozambique?
Your answer should be very brief. -2.61. In the year 2004, what is the difference between the Exports(as % of merchandise exports) of Belgium and Exports(as % of merchandise exports) of Kuwait?
Ensure brevity in your answer.  1.21. In the year 2004, what is the difference between the Exports(as % of merchandise exports) of Belgium and Exports(as % of merchandise exports) of Mozambique?
Give a very brief answer. -3.12. In the year 2004, what is the difference between the Exports(as % of merchandise exports) of Kuwait and Exports(as % of merchandise exports) of Mozambique?
Give a very brief answer. -4.33. What is the ratio of the Exports(as % of merchandise exports) in Middle income in 1997 to that in 1999?
Provide a succinct answer. 1.18. What is the ratio of the Exports(as % of merchandise exports) of Belgium in 1997 to that in 1999?
Ensure brevity in your answer.  0.88. What is the ratio of the Exports(as % of merchandise exports) of Kuwait in 1997 to that in 1999?
Offer a terse response. 1.1. What is the ratio of the Exports(as % of merchandise exports) in Mozambique in 1997 to that in 1999?
Your answer should be compact. 1.24. What is the ratio of the Exports(as % of merchandise exports) of Middle income in 1997 to that in 2000?
Keep it short and to the point. 1.24. What is the ratio of the Exports(as % of merchandise exports) of Belgium in 1997 to that in 2000?
Offer a very short reply. 0.8. What is the ratio of the Exports(as % of merchandise exports) in Kuwait in 1997 to that in 2000?
Your answer should be compact. 4.17. What is the ratio of the Exports(as % of merchandise exports) in Mozambique in 1997 to that in 2000?
Offer a very short reply. 1.22. What is the ratio of the Exports(as % of merchandise exports) of Middle income in 1997 to that in 2001?
Give a very brief answer. 1.4. What is the ratio of the Exports(as % of merchandise exports) of Belgium in 1997 to that in 2001?
Provide a succinct answer. 0.93. What is the ratio of the Exports(as % of merchandise exports) of Kuwait in 1997 to that in 2001?
Keep it short and to the point. 6.99. What is the ratio of the Exports(as % of merchandise exports) in Mozambique in 1997 to that in 2001?
Give a very brief answer. 3.42. What is the ratio of the Exports(as % of merchandise exports) in Middle income in 1997 to that in 2002?
Your response must be concise. 1.4. What is the ratio of the Exports(as % of merchandise exports) in Kuwait in 1997 to that in 2002?
Ensure brevity in your answer.  4.15. What is the ratio of the Exports(as % of merchandise exports) of Mozambique in 1997 to that in 2002?
Your response must be concise. 3.27. What is the ratio of the Exports(as % of merchandise exports) of Middle income in 1997 to that in 2003?
Keep it short and to the point. 1.29. What is the ratio of the Exports(as % of merchandise exports) of Belgium in 1997 to that in 2003?
Keep it short and to the point. 0.99. What is the ratio of the Exports(as % of merchandise exports) in Kuwait in 1997 to that in 2003?
Your response must be concise. 8.11. What is the ratio of the Exports(as % of merchandise exports) in Mozambique in 1997 to that in 2003?
Your response must be concise. 2.69. What is the ratio of the Exports(as % of merchandise exports) of Middle income in 1997 to that in 2004?
Your answer should be compact. 1.39. What is the ratio of the Exports(as % of merchandise exports) in Kuwait in 1997 to that in 2004?
Make the answer very short. 8.17. What is the ratio of the Exports(as % of merchandise exports) in Mozambique in 1997 to that in 2004?
Give a very brief answer. 3.18. What is the ratio of the Exports(as % of merchandise exports) in Middle income in 1999 to that in 2000?
Give a very brief answer. 1.05. What is the ratio of the Exports(as % of merchandise exports) of Belgium in 1999 to that in 2000?
Provide a succinct answer. 0.9. What is the ratio of the Exports(as % of merchandise exports) of Kuwait in 1999 to that in 2000?
Provide a succinct answer. 3.8. What is the ratio of the Exports(as % of merchandise exports) of Mozambique in 1999 to that in 2000?
Your answer should be very brief. 0.98. What is the ratio of the Exports(as % of merchandise exports) in Middle income in 1999 to that in 2001?
Make the answer very short. 1.19. What is the ratio of the Exports(as % of merchandise exports) in Belgium in 1999 to that in 2001?
Make the answer very short. 1.05. What is the ratio of the Exports(as % of merchandise exports) of Kuwait in 1999 to that in 2001?
Ensure brevity in your answer.  6.37. What is the ratio of the Exports(as % of merchandise exports) in Mozambique in 1999 to that in 2001?
Make the answer very short. 2.74. What is the ratio of the Exports(as % of merchandise exports) in Middle income in 1999 to that in 2002?
Your response must be concise. 1.18. What is the ratio of the Exports(as % of merchandise exports) in Belgium in 1999 to that in 2002?
Your response must be concise. 1.14. What is the ratio of the Exports(as % of merchandise exports) of Kuwait in 1999 to that in 2002?
Ensure brevity in your answer.  3.78. What is the ratio of the Exports(as % of merchandise exports) in Mozambique in 1999 to that in 2002?
Offer a very short reply. 2.63. What is the ratio of the Exports(as % of merchandise exports) of Middle income in 1999 to that in 2003?
Keep it short and to the point. 1.09. What is the ratio of the Exports(as % of merchandise exports) in Belgium in 1999 to that in 2003?
Your answer should be compact. 1.12. What is the ratio of the Exports(as % of merchandise exports) of Kuwait in 1999 to that in 2003?
Provide a succinct answer. 7.38. What is the ratio of the Exports(as % of merchandise exports) of Mozambique in 1999 to that in 2003?
Provide a succinct answer. 2.16. What is the ratio of the Exports(as % of merchandise exports) of Middle income in 1999 to that in 2004?
Offer a terse response. 1.18. What is the ratio of the Exports(as % of merchandise exports) of Belgium in 1999 to that in 2004?
Ensure brevity in your answer.  1.13. What is the ratio of the Exports(as % of merchandise exports) of Kuwait in 1999 to that in 2004?
Ensure brevity in your answer.  7.44. What is the ratio of the Exports(as % of merchandise exports) in Mozambique in 1999 to that in 2004?
Provide a succinct answer. 2.55. What is the ratio of the Exports(as % of merchandise exports) in Middle income in 2000 to that in 2001?
Give a very brief answer. 1.13. What is the ratio of the Exports(as % of merchandise exports) in Belgium in 2000 to that in 2001?
Ensure brevity in your answer.  1.16. What is the ratio of the Exports(as % of merchandise exports) in Kuwait in 2000 to that in 2001?
Give a very brief answer. 1.68. What is the ratio of the Exports(as % of merchandise exports) in Mozambique in 2000 to that in 2001?
Offer a very short reply. 2.81. What is the ratio of the Exports(as % of merchandise exports) in Middle income in 2000 to that in 2002?
Keep it short and to the point. 1.12. What is the ratio of the Exports(as % of merchandise exports) in Belgium in 2000 to that in 2002?
Give a very brief answer. 1.26. What is the ratio of the Exports(as % of merchandise exports) in Mozambique in 2000 to that in 2002?
Offer a very short reply. 2.7. What is the ratio of the Exports(as % of merchandise exports) in Middle income in 2000 to that in 2003?
Keep it short and to the point. 1.03. What is the ratio of the Exports(as % of merchandise exports) in Belgium in 2000 to that in 2003?
Keep it short and to the point. 1.24. What is the ratio of the Exports(as % of merchandise exports) of Kuwait in 2000 to that in 2003?
Keep it short and to the point. 1.94. What is the ratio of the Exports(as % of merchandise exports) of Mozambique in 2000 to that in 2003?
Provide a succinct answer. 2.21. What is the ratio of the Exports(as % of merchandise exports) of Middle income in 2000 to that in 2004?
Your answer should be compact. 1.12. What is the ratio of the Exports(as % of merchandise exports) of Belgium in 2000 to that in 2004?
Keep it short and to the point. 1.25. What is the ratio of the Exports(as % of merchandise exports) of Kuwait in 2000 to that in 2004?
Make the answer very short. 1.96. What is the ratio of the Exports(as % of merchandise exports) in Mozambique in 2000 to that in 2004?
Your response must be concise. 2.61. What is the ratio of the Exports(as % of merchandise exports) of Belgium in 2001 to that in 2002?
Your answer should be compact. 1.08. What is the ratio of the Exports(as % of merchandise exports) in Kuwait in 2001 to that in 2002?
Offer a very short reply. 0.59. What is the ratio of the Exports(as % of merchandise exports) in Mozambique in 2001 to that in 2002?
Provide a short and direct response. 0.96. What is the ratio of the Exports(as % of merchandise exports) in Middle income in 2001 to that in 2003?
Offer a terse response. 0.92. What is the ratio of the Exports(as % of merchandise exports) of Belgium in 2001 to that in 2003?
Offer a very short reply. 1.06. What is the ratio of the Exports(as % of merchandise exports) in Kuwait in 2001 to that in 2003?
Ensure brevity in your answer.  1.16. What is the ratio of the Exports(as % of merchandise exports) of Mozambique in 2001 to that in 2003?
Your response must be concise. 0.79. What is the ratio of the Exports(as % of merchandise exports) of Belgium in 2001 to that in 2004?
Offer a very short reply. 1.07. What is the ratio of the Exports(as % of merchandise exports) of Kuwait in 2001 to that in 2004?
Keep it short and to the point. 1.17. What is the ratio of the Exports(as % of merchandise exports) in Mozambique in 2001 to that in 2004?
Offer a very short reply. 0.93. What is the ratio of the Exports(as % of merchandise exports) of Middle income in 2002 to that in 2003?
Provide a succinct answer. 0.92. What is the ratio of the Exports(as % of merchandise exports) in Belgium in 2002 to that in 2003?
Offer a terse response. 0.98. What is the ratio of the Exports(as % of merchandise exports) in Kuwait in 2002 to that in 2003?
Give a very brief answer. 1.96. What is the ratio of the Exports(as % of merchandise exports) in Mozambique in 2002 to that in 2003?
Give a very brief answer. 0.82. What is the ratio of the Exports(as % of merchandise exports) of Middle income in 2002 to that in 2004?
Offer a terse response. 1. What is the ratio of the Exports(as % of merchandise exports) in Kuwait in 2002 to that in 2004?
Keep it short and to the point. 1.97. What is the ratio of the Exports(as % of merchandise exports) in Mozambique in 2002 to that in 2004?
Keep it short and to the point. 0.97. What is the ratio of the Exports(as % of merchandise exports) of Middle income in 2003 to that in 2004?
Your response must be concise. 1.08. What is the ratio of the Exports(as % of merchandise exports) in Belgium in 2003 to that in 2004?
Ensure brevity in your answer.  1.01. What is the ratio of the Exports(as % of merchandise exports) in Kuwait in 2003 to that in 2004?
Your answer should be very brief. 1.01. What is the ratio of the Exports(as % of merchandise exports) of Mozambique in 2003 to that in 2004?
Offer a terse response. 1.18. What is the difference between the highest and the second highest Exports(as % of merchandise exports) of Middle income?
Provide a short and direct response. 0.37. What is the difference between the highest and the second highest Exports(as % of merchandise exports) in Belgium?
Ensure brevity in your answer.  0.15. What is the difference between the highest and the second highest Exports(as % of merchandise exports) of Kuwait?
Give a very brief answer. 0.01. What is the difference between the highest and the second highest Exports(as % of merchandise exports) in Mozambique?
Provide a succinct answer. 2.44. What is the difference between the highest and the lowest Exports(as % of merchandise exports) in Middle income?
Offer a very short reply. 0.69. What is the difference between the highest and the lowest Exports(as % of merchandise exports) of Belgium?
Your answer should be very brief. 0.31. What is the difference between the highest and the lowest Exports(as % of merchandise exports) of Kuwait?
Your answer should be very brief. 0.05. What is the difference between the highest and the lowest Exports(as % of merchandise exports) in Mozambique?
Ensure brevity in your answer.  9.74. 